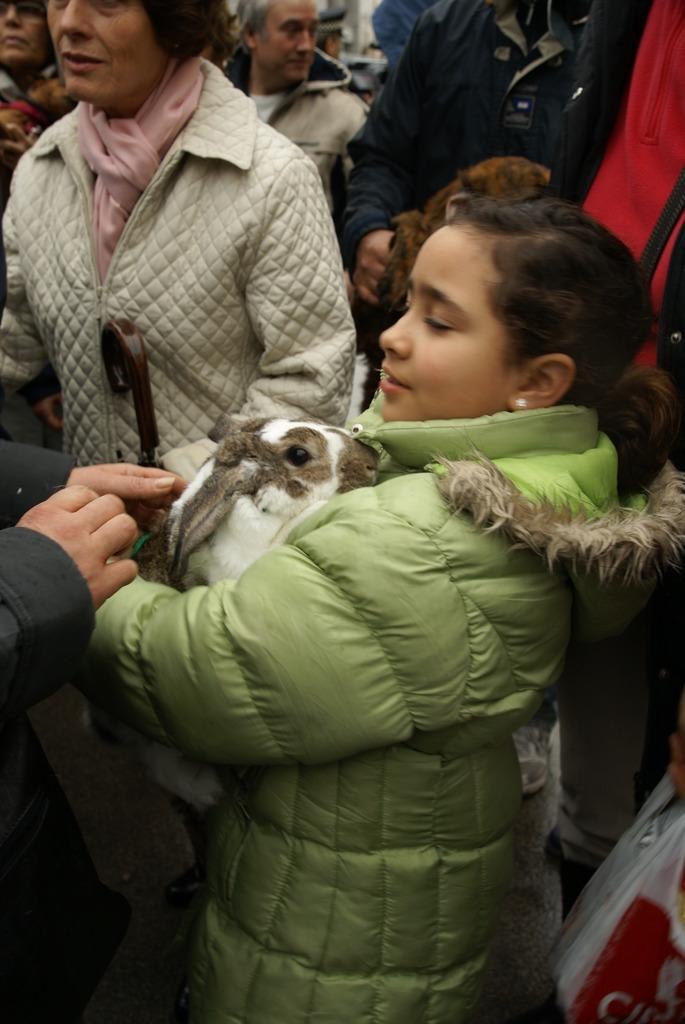Could you give a brief overview of what you see in this image? In this image we can see people standing on the floor and some of them are holding animals in their hands. 